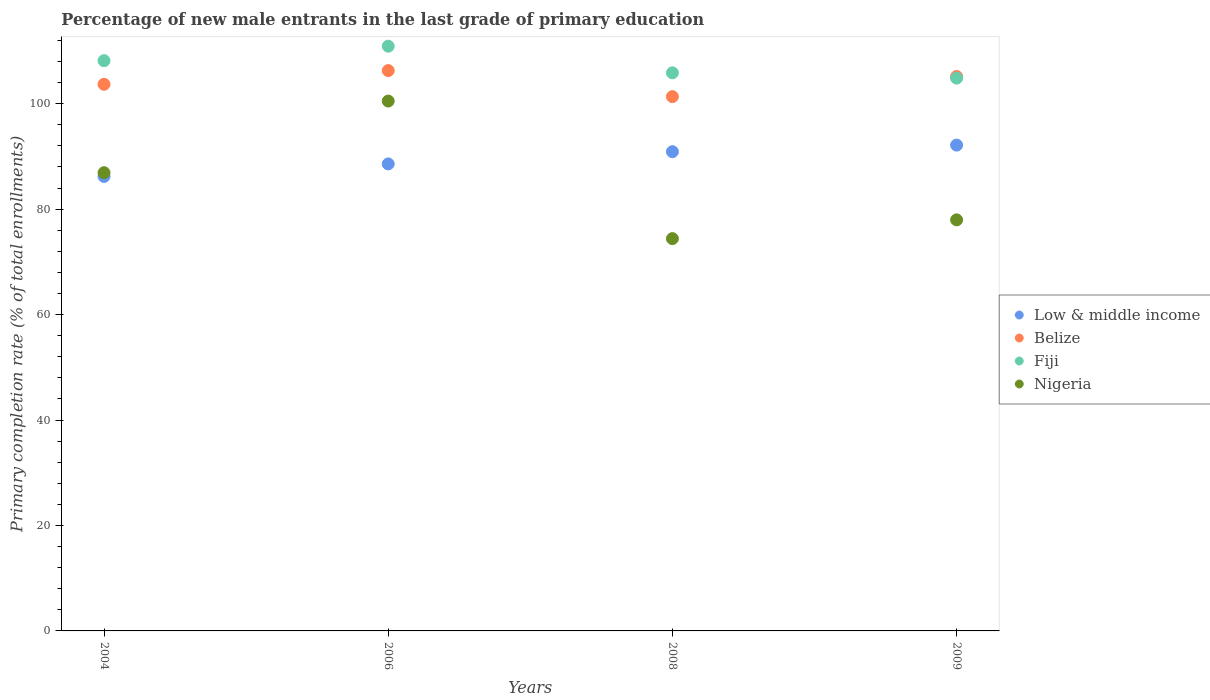How many different coloured dotlines are there?
Offer a terse response. 4. What is the percentage of new male entrants in Fiji in 2008?
Provide a short and direct response. 105.85. Across all years, what is the maximum percentage of new male entrants in Low & middle income?
Keep it short and to the point. 92.14. Across all years, what is the minimum percentage of new male entrants in Nigeria?
Provide a succinct answer. 74.41. In which year was the percentage of new male entrants in Belize maximum?
Offer a very short reply. 2006. What is the total percentage of new male entrants in Nigeria in the graph?
Provide a succinct answer. 339.77. What is the difference between the percentage of new male entrants in Nigeria in 2006 and that in 2009?
Give a very brief answer. 22.53. What is the difference between the percentage of new male entrants in Nigeria in 2004 and the percentage of new male entrants in Low & middle income in 2008?
Offer a very short reply. -3.99. What is the average percentage of new male entrants in Low & middle income per year?
Offer a very short reply. 89.45. In the year 2009, what is the difference between the percentage of new male entrants in Nigeria and percentage of new male entrants in Fiji?
Offer a terse response. -26.89. In how many years, is the percentage of new male entrants in Nigeria greater than 76 %?
Keep it short and to the point. 3. What is the ratio of the percentage of new male entrants in Fiji in 2006 to that in 2008?
Offer a terse response. 1.05. Is the percentage of new male entrants in Belize in 2004 less than that in 2006?
Your answer should be compact. Yes. Is the difference between the percentage of new male entrants in Nigeria in 2006 and 2008 greater than the difference between the percentage of new male entrants in Fiji in 2006 and 2008?
Make the answer very short. Yes. What is the difference between the highest and the second highest percentage of new male entrants in Belize?
Provide a succinct answer. 1.12. What is the difference between the highest and the lowest percentage of new male entrants in Nigeria?
Your response must be concise. 26.09. In how many years, is the percentage of new male entrants in Low & middle income greater than the average percentage of new male entrants in Low & middle income taken over all years?
Your answer should be compact. 2. Is the sum of the percentage of new male entrants in Low & middle income in 2004 and 2006 greater than the maximum percentage of new male entrants in Fiji across all years?
Provide a short and direct response. Yes. Is it the case that in every year, the sum of the percentage of new male entrants in Belize and percentage of new male entrants in Fiji  is greater than the sum of percentage of new male entrants in Nigeria and percentage of new male entrants in Low & middle income?
Your answer should be very brief. No. Does the percentage of new male entrants in Belize monotonically increase over the years?
Keep it short and to the point. No. How many dotlines are there?
Offer a terse response. 4. What is the difference between two consecutive major ticks on the Y-axis?
Your answer should be very brief. 20. Does the graph contain any zero values?
Offer a very short reply. No. Does the graph contain grids?
Your answer should be compact. No. How are the legend labels stacked?
Offer a very short reply. Vertical. What is the title of the graph?
Give a very brief answer. Percentage of new male entrants in the last grade of primary education. Does "Vietnam" appear as one of the legend labels in the graph?
Provide a short and direct response. No. What is the label or title of the Y-axis?
Offer a terse response. Primary completion rate (% of total enrollments). What is the Primary completion rate (% of total enrollments) in Low & middle income in 2004?
Offer a very short reply. 86.2. What is the Primary completion rate (% of total enrollments) of Belize in 2004?
Your answer should be compact. 103.67. What is the Primary completion rate (% of total enrollments) in Fiji in 2004?
Your answer should be compact. 108.15. What is the Primary completion rate (% of total enrollments) of Nigeria in 2004?
Provide a succinct answer. 86.91. What is the Primary completion rate (% of total enrollments) of Low & middle income in 2006?
Ensure brevity in your answer.  88.58. What is the Primary completion rate (% of total enrollments) of Belize in 2006?
Offer a very short reply. 106.28. What is the Primary completion rate (% of total enrollments) in Fiji in 2006?
Offer a very short reply. 110.9. What is the Primary completion rate (% of total enrollments) in Nigeria in 2006?
Your answer should be very brief. 100.5. What is the Primary completion rate (% of total enrollments) in Low & middle income in 2008?
Provide a short and direct response. 90.89. What is the Primary completion rate (% of total enrollments) of Belize in 2008?
Offer a very short reply. 101.34. What is the Primary completion rate (% of total enrollments) of Fiji in 2008?
Keep it short and to the point. 105.85. What is the Primary completion rate (% of total enrollments) of Nigeria in 2008?
Offer a terse response. 74.41. What is the Primary completion rate (% of total enrollments) in Low & middle income in 2009?
Offer a very short reply. 92.14. What is the Primary completion rate (% of total enrollments) of Belize in 2009?
Provide a succinct answer. 105.16. What is the Primary completion rate (% of total enrollments) of Fiji in 2009?
Your response must be concise. 104.85. What is the Primary completion rate (% of total enrollments) of Nigeria in 2009?
Offer a terse response. 77.96. Across all years, what is the maximum Primary completion rate (% of total enrollments) in Low & middle income?
Provide a succinct answer. 92.14. Across all years, what is the maximum Primary completion rate (% of total enrollments) in Belize?
Keep it short and to the point. 106.28. Across all years, what is the maximum Primary completion rate (% of total enrollments) of Fiji?
Your answer should be compact. 110.9. Across all years, what is the maximum Primary completion rate (% of total enrollments) of Nigeria?
Offer a terse response. 100.5. Across all years, what is the minimum Primary completion rate (% of total enrollments) of Low & middle income?
Offer a very short reply. 86.2. Across all years, what is the minimum Primary completion rate (% of total enrollments) of Belize?
Provide a short and direct response. 101.34. Across all years, what is the minimum Primary completion rate (% of total enrollments) of Fiji?
Provide a succinct answer. 104.85. Across all years, what is the minimum Primary completion rate (% of total enrollments) in Nigeria?
Offer a terse response. 74.41. What is the total Primary completion rate (% of total enrollments) of Low & middle income in the graph?
Your answer should be very brief. 357.82. What is the total Primary completion rate (% of total enrollments) in Belize in the graph?
Your response must be concise. 416.45. What is the total Primary completion rate (% of total enrollments) of Fiji in the graph?
Ensure brevity in your answer.  429.76. What is the total Primary completion rate (% of total enrollments) of Nigeria in the graph?
Give a very brief answer. 339.77. What is the difference between the Primary completion rate (% of total enrollments) in Low & middle income in 2004 and that in 2006?
Keep it short and to the point. -2.37. What is the difference between the Primary completion rate (% of total enrollments) of Belize in 2004 and that in 2006?
Keep it short and to the point. -2.61. What is the difference between the Primary completion rate (% of total enrollments) in Fiji in 2004 and that in 2006?
Keep it short and to the point. -2.75. What is the difference between the Primary completion rate (% of total enrollments) of Nigeria in 2004 and that in 2006?
Offer a very short reply. -13.59. What is the difference between the Primary completion rate (% of total enrollments) in Low & middle income in 2004 and that in 2008?
Keep it short and to the point. -4.69. What is the difference between the Primary completion rate (% of total enrollments) in Belize in 2004 and that in 2008?
Give a very brief answer. 2.34. What is the difference between the Primary completion rate (% of total enrollments) of Fiji in 2004 and that in 2008?
Ensure brevity in your answer.  2.3. What is the difference between the Primary completion rate (% of total enrollments) of Nigeria in 2004 and that in 2008?
Ensure brevity in your answer.  12.5. What is the difference between the Primary completion rate (% of total enrollments) in Low & middle income in 2004 and that in 2009?
Offer a terse response. -5.94. What is the difference between the Primary completion rate (% of total enrollments) in Belize in 2004 and that in 2009?
Offer a very short reply. -1.48. What is the difference between the Primary completion rate (% of total enrollments) of Fiji in 2004 and that in 2009?
Your answer should be compact. 3.3. What is the difference between the Primary completion rate (% of total enrollments) of Nigeria in 2004 and that in 2009?
Ensure brevity in your answer.  8.94. What is the difference between the Primary completion rate (% of total enrollments) of Low & middle income in 2006 and that in 2008?
Provide a succinct answer. -2.32. What is the difference between the Primary completion rate (% of total enrollments) of Belize in 2006 and that in 2008?
Offer a terse response. 4.94. What is the difference between the Primary completion rate (% of total enrollments) of Fiji in 2006 and that in 2008?
Give a very brief answer. 5.05. What is the difference between the Primary completion rate (% of total enrollments) in Nigeria in 2006 and that in 2008?
Provide a short and direct response. 26.09. What is the difference between the Primary completion rate (% of total enrollments) in Low & middle income in 2006 and that in 2009?
Give a very brief answer. -3.57. What is the difference between the Primary completion rate (% of total enrollments) of Belize in 2006 and that in 2009?
Your response must be concise. 1.12. What is the difference between the Primary completion rate (% of total enrollments) in Fiji in 2006 and that in 2009?
Provide a succinct answer. 6.05. What is the difference between the Primary completion rate (% of total enrollments) of Nigeria in 2006 and that in 2009?
Keep it short and to the point. 22.53. What is the difference between the Primary completion rate (% of total enrollments) of Low & middle income in 2008 and that in 2009?
Ensure brevity in your answer.  -1.25. What is the difference between the Primary completion rate (% of total enrollments) in Belize in 2008 and that in 2009?
Make the answer very short. -3.82. What is the difference between the Primary completion rate (% of total enrollments) of Nigeria in 2008 and that in 2009?
Make the answer very short. -3.56. What is the difference between the Primary completion rate (% of total enrollments) in Low & middle income in 2004 and the Primary completion rate (% of total enrollments) in Belize in 2006?
Make the answer very short. -20.08. What is the difference between the Primary completion rate (% of total enrollments) in Low & middle income in 2004 and the Primary completion rate (% of total enrollments) in Fiji in 2006?
Your answer should be compact. -24.7. What is the difference between the Primary completion rate (% of total enrollments) of Low & middle income in 2004 and the Primary completion rate (% of total enrollments) of Nigeria in 2006?
Give a very brief answer. -14.29. What is the difference between the Primary completion rate (% of total enrollments) of Belize in 2004 and the Primary completion rate (% of total enrollments) of Fiji in 2006?
Your answer should be compact. -7.23. What is the difference between the Primary completion rate (% of total enrollments) of Belize in 2004 and the Primary completion rate (% of total enrollments) of Nigeria in 2006?
Your response must be concise. 3.18. What is the difference between the Primary completion rate (% of total enrollments) of Fiji in 2004 and the Primary completion rate (% of total enrollments) of Nigeria in 2006?
Provide a short and direct response. 7.66. What is the difference between the Primary completion rate (% of total enrollments) in Low & middle income in 2004 and the Primary completion rate (% of total enrollments) in Belize in 2008?
Offer a terse response. -15.13. What is the difference between the Primary completion rate (% of total enrollments) of Low & middle income in 2004 and the Primary completion rate (% of total enrollments) of Fiji in 2008?
Make the answer very short. -19.65. What is the difference between the Primary completion rate (% of total enrollments) in Low & middle income in 2004 and the Primary completion rate (% of total enrollments) in Nigeria in 2008?
Provide a short and direct response. 11.8. What is the difference between the Primary completion rate (% of total enrollments) in Belize in 2004 and the Primary completion rate (% of total enrollments) in Fiji in 2008?
Provide a succinct answer. -2.18. What is the difference between the Primary completion rate (% of total enrollments) of Belize in 2004 and the Primary completion rate (% of total enrollments) of Nigeria in 2008?
Make the answer very short. 29.27. What is the difference between the Primary completion rate (% of total enrollments) in Fiji in 2004 and the Primary completion rate (% of total enrollments) in Nigeria in 2008?
Provide a succinct answer. 33.75. What is the difference between the Primary completion rate (% of total enrollments) in Low & middle income in 2004 and the Primary completion rate (% of total enrollments) in Belize in 2009?
Your answer should be very brief. -18.95. What is the difference between the Primary completion rate (% of total enrollments) in Low & middle income in 2004 and the Primary completion rate (% of total enrollments) in Fiji in 2009?
Your answer should be compact. -18.65. What is the difference between the Primary completion rate (% of total enrollments) of Low & middle income in 2004 and the Primary completion rate (% of total enrollments) of Nigeria in 2009?
Provide a short and direct response. 8.24. What is the difference between the Primary completion rate (% of total enrollments) in Belize in 2004 and the Primary completion rate (% of total enrollments) in Fiji in 2009?
Provide a succinct answer. -1.18. What is the difference between the Primary completion rate (% of total enrollments) in Belize in 2004 and the Primary completion rate (% of total enrollments) in Nigeria in 2009?
Your answer should be compact. 25.71. What is the difference between the Primary completion rate (% of total enrollments) of Fiji in 2004 and the Primary completion rate (% of total enrollments) of Nigeria in 2009?
Keep it short and to the point. 30.19. What is the difference between the Primary completion rate (% of total enrollments) in Low & middle income in 2006 and the Primary completion rate (% of total enrollments) in Belize in 2008?
Offer a terse response. -12.76. What is the difference between the Primary completion rate (% of total enrollments) in Low & middle income in 2006 and the Primary completion rate (% of total enrollments) in Fiji in 2008?
Your answer should be compact. -17.27. What is the difference between the Primary completion rate (% of total enrollments) in Low & middle income in 2006 and the Primary completion rate (% of total enrollments) in Nigeria in 2008?
Your response must be concise. 14.17. What is the difference between the Primary completion rate (% of total enrollments) in Belize in 2006 and the Primary completion rate (% of total enrollments) in Fiji in 2008?
Offer a very short reply. 0.43. What is the difference between the Primary completion rate (% of total enrollments) of Belize in 2006 and the Primary completion rate (% of total enrollments) of Nigeria in 2008?
Give a very brief answer. 31.88. What is the difference between the Primary completion rate (% of total enrollments) of Fiji in 2006 and the Primary completion rate (% of total enrollments) of Nigeria in 2008?
Provide a succinct answer. 36.5. What is the difference between the Primary completion rate (% of total enrollments) of Low & middle income in 2006 and the Primary completion rate (% of total enrollments) of Belize in 2009?
Your answer should be compact. -16.58. What is the difference between the Primary completion rate (% of total enrollments) in Low & middle income in 2006 and the Primary completion rate (% of total enrollments) in Fiji in 2009?
Your answer should be very brief. -16.27. What is the difference between the Primary completion rate (% of total enrollments) in Low & middle income in 2006 and the Primary completion rate (% of total enrollments) in Nigeria in 2009?
Make the answer very short. 10.61. What is the difference between the Primary completion rate (% of total enrollments) in Belize in 2006 and the Primary completion rate (% of total enrollments) in Fiji in 2009?
Provide a succinct answer. 1.43. What is the difference between the Primary completion rate (% of total enrollments) in Belize in 2006 and the Primary completion rate (% of total enrollments) in Nigeria in 2009?
Provide a short and direct response. 28.32. What is the difference between the Primary completion rate (% of total enrollments) in Fiji in 2006 and the Primary completion rate (% of total enrollments) in Nigeria in 2009?
Provide a short and direct response. 32.94. What is the difference between the Primary completion rate (% of total enrollments) in Low & middle income in 2008 and the Primary completion rate (% of total enrollments) in Belize in 2009?
Provide a succinct answer. -14.26. What is the difference between the Primary completion rate (% of total enrollments) in Low & middle income in 2008 and the Primary completion rate (% of total enrollments) in Fiji in 2009?
Make the answer very short. -13.96. What is the difference between the Primary completion rate (% of total enrollments) of Low & middle income in 2008 and the Primary completion rate (% of total enrollments) of Nigeria in 2009?
Offer a very short reply. 12.93. What is the difference between the Primary completion rate (% of total enrollments) of Belize in 2008 and the Primary completion rate (% of total enrollments) of Fiji in 2009?
Give a very brief answer. -3.51. What is the difference between the Primary completion rate (% of total enrollments) of Belize in 2008 and the Primary completion rate (% of total enrollments) of Nigeria in 2009?
Provide a short and direct response. 23.37. What is the difference between the Primary completion rate (% of total enrollments) in Fiji in 2008 and the Primary completion rate (% of total enrollments) in Nigeria in 2009?
Ensure brevity in your answer.  27.89. What is the average Primary completion rate (% of total enrollments) in Low & middle income per year?
Your response must be concise. 89.45. What is the average Primary completion rate (% of total enrollments) in Belize per year?
Your response must be concise. 104.11. What is the average Primary completion rate (% of total enrollments) of Fiji per year?
Provide a short and direct response. 107.44. What is the average Primary completion rate (% of total enrollments) in Nigeria per year?
Make the answer very short. 84.94. In the year 2004, what is the difference between the Primary completion rate (% of total enrollments) of Low & middle income and Primary completion rate (% of total enrollments) of Belize?
Provide a succinct answer. -17.47. In the year 2004, what is the difference between the Primary completion rate (% of total enrollments) of Low & middle income and Primary completion rate (% of total enrollments) of Fiji?
Ensure brevity in your answer.  -21.95. In the year 2004, what is the difference between the Primary completion rate (% of total enrollments) in Low & middle income and Primary completion rate (% of total enrollments) in Nigeria?
Give a very brief answer. -0.7. In the year 2004, what is the difference between the Primary completion rate (% of total enrollments) of Belize and Primary completion rate (% of total enrollments) of Fiji?
Ensure brevity in your answer.  -4.48. In the year 2004, what is the difference between the Primary completion rate (% of total enrollments) of Belize and Primary completion rate (% of total enrollments) of Nigeria?
Offer a very short reply. 16.77. In the year 2004, what is the difference between the Primary completion rate (% of total enrollments) in Fiji and Primary completion rate (% of total enrollments) in Nigeria?
Give a very brief answer. 21.25. In the year 2006, what is the difference between the Primary completion rate (% of total enrollments) of Low & middle income and Primary completion rate (% of total enrollments) of Belize?
Provide a succinct answer. -17.71. In the year 2006, what is the difference between the Primary completion rate (% of total enrollments) in Low & middle income and Primary completion rate (% of total enrollments) in Fiji?
Ensure brevity in your answer.  -22.33. In the year 2006, what is the difference between the Primary completion rate (% of total enrollments) of Low & middle income and Primary completion rate (% of total enrollments) of Nigeria?
Provide a short and direct response. -11.92. In the year 2006, what is the difference between the Primary completion rate (% of total enrollments) in Belize and Primary completion rate (% of total enrollments) in Fiji?
Your answer should be compact. -4.62. In the year 2006, what is the difference between the Primary completion rate (% of total enrollments) of Belize and Primary completion rate (% of total enrollments) of Nigeria?
Give a very brief answer. 5.78. In the year 2006, what is the difference between the Primary completion rate (% of total enrollments) of Fiji and Primary completion rate (% of total enrollments) of Nigeria?
Ensure brevity in your answer.  10.41. In the year 2008, what is the difference between the Primary completion rate (% of total enrollments) in Low & middle income and Primary completion rate (% of total enrollments) in Belize?
Offer a very short reply. -10.44. In the year 2008, what is the difference between the Primary completion rate (% of total enrollments) of Low & middle income and Primary completion rate (% of total enrollments) of Fiji?
Offer a very short reply. -14.96. In the year 2008, what is the difference between the Primary completion rate (% of total enrollments) of Low & middle income and Primary completion rate (% of total enrollments) of Nigeria?
Your answer should be very brief. 16.49. In the year 2008, what is the difference between the Primary completion rate (% of total enrollments) of Belize and Primary completion rate (% of total enrollments) of Fiji?
Ensure brevity in your answer.  -4.51. In the year 2008, what is the difference between the Primary completion rate (% of total enrollments) of Belize and Primary completion rate (% of total enrollments) of Nigeria?
Your answer should be compact. 26.93. In the year 2008, what is the difference between the Primary completion rate (% of total enrollments) of Fiji and Primary completion rate (% of total enrollments) of Nigeria?
Offer a terse response. 31.44. In the year 2009, what is the difference between the Primary completion rate (% of total enrollments) of Low & middle income and Primary completion rate (% of total enrollments) of Belize?
Your answer should be very brief. -13.01. In the year 2009, what is the difference between the Primary completion rate (% of total enrollments) in Low & middle income and Primary completion rate (% of total enrollments) in Fiji?
Your answer should be very brief. -12.71. In the year 2009, what is the difference between the Primary completion rate (% of total enrollments) in Low & middle income and Primary completion rate (% of total enrollments) in Nigeria?
Offer a very short reply. 14.18. In the year 2009, what is the difference between the Primary completion rate (% of total enrollments) of Belize and Primary completion rate (% of total enrollments) of Fiji?
Your answer should be very brief. 0.31. In the year 2009, what is the difference between the Primary completion rate (% of total enrollments) of Belize and Primary completion rate (% of total enrollments) of Nigeria?
Offer a very short reply. 27.19. In the year 2009, what is the difference between the Primary completion rate (% of total enrollments) in Fiji and Primary completion rate (% of total enrollments) in Nigeria?
Offer a very short reply. 26.89. What is the ratio of the Primary completion rate (% of total enrollments) of Low & middle income in 2004 to that in 2006?
Give a very brief answer. 0.97. What is the ratio of the Primary completion rate (% of total enrollments) of Belize in 2004 to that in 2006?
Offer a very short reply. 0.98. What is the ratio of the Primary completion rate (% of total enrollments) of Fiji in 2004 to that in 2006?
Your answer should be very brief. 0.98. What is the ratio of the Primary completion rate (% of total enrollments) of Nigeria in 2004 to that in 2006?
Your answer should be very brief. 0.86. What is the ratio of the Primary completion rate (% of total enrollments) of Low & middle income in 2004 to that in 2008?
Provide a succinct answer. 0.95. What is the ratio of the Primary completion rate (% of total enrollments) in Belize in 2004 to that in 2008?
Your answer should be compact. 1.02. What is the ratio of the Primary completion rate (% of total enrollments) in Fiji in 2004 to that in 2008?
Your response must be concise. 1.02. What is the ratio of the Primary completion rate (% of total enrollments) of Nigeria in 2004 to that in 2008?
Your answer should be compact. 1.17. What is the ratio of the Primary completion rate (% of total enrollments) of Low & middle income in 2004 to that in 2009?
Offer a very short reply. 0.94. What is the ratio of the Primary completion rate (% of total enrollments) of Belize in 2004 to that in 2009?
Your response must be concise. 0.99. What is the ratio of the Primary completion rate (% of total enrollments) in Fiji in 2004 to that in 2009?
Give a very brief answer. 1.03. What is the ratio of the Primary completion rate (% of total enrollments) in Nigeria in 2004 to that in 2009?
Give a very brief answer. 1.11. What is the ratio of the Primary completion rate (% of total enrollments) of Low & middle income in 2006 to that in 2008?
Make the answer very short. 0.97. What is the ratio of the Primary completion rate (% of total enrollments) of Belize in 2006 to that in 2008?
Keep it short and to the point. 1.05. What is the ratio of the Primary completion rate (% of total enrollments) of Fiji in 2006 to that in 2008?
Offer a terse response. 1.05. What is the ratio of the Primary completion rate (% of total enrollments) of Nigeria in 2006 to that in 2008?
Your answer should be compact. 1.35. What is the ratio of the Primary completion rate (% of total enrollments) in Low & middle income in 2006 to that in 2009?
Provide a succinct answer. 0.96. What is the ratio of the Primary completion rate (% of total enrollments) of Belize in 2006 to that in 2009?
Offer a terse response. 1.01. What is the ratio of the Primary completion rate (% of total enrollments) in Fiji in 2006 to that in 2009?
Make the answer very short. 1.06. What is the ratio of the Primary completion rate (% of total enrollments) in Nigeria in 2006 to that in 2009?
Your answer should be compact. 1.29. What is the ratio of the Primary completion rate (% of total enrollments) of Low & middle income in 2008 to that in 2009?
Offer a terse response. 0.99. What is the ratio of the Primary completion rate (% of total enrollments) of Belize in 2008 to that in 2009?
Your answer should be very brief. 0.96. What is the ratio of the Primary completion rate (% of total enrollments) in Fiji in 2008 to that in 2009?
Make the answer very short. 1.01. What is the ratio of the Primary completion rate (% of total enrollments) in Nigeria in 2008 to that in 2009?
Keep it short and to the point. 0.95. What is the difference between the highest and the second highest Primary completion rate (% of total enrollments) of Low & middle income?
Offer a very short reply. 1.25. What is the difference between the highest and the second highest Primary completion rate (% of total enrollments) in Belize?
Provide a succinct answer. 1.12. What is the difference between the highest and the second highest Primary completion rate (% of total enrollments) of Fiji?
Offer a terse response. 2.75. What is the difference between the highest and the second highest Primary completion rate (% of total enrollments) of Nigeria?
Offer a terse response. 13.59. What is the difference between the highest and the lowest Primary completion rate (% of total enrollments) of Low & middle income?
Ensure brevity in your answer.  5.94. What is the difference between the highest and the lowest Primary completion rate (% of total enrollments) in Belize?
Your response must be concise. 4.94. What is the difference between the highest and the lowest Primary completion rate (% of total enrollments) of Fiji?
Offer a very short reply. 6.05. What is the difference between the highest and the lowest Primary completion rate (% of total enrollments) of Nigeria?
Make the answer very short. 26.09. 